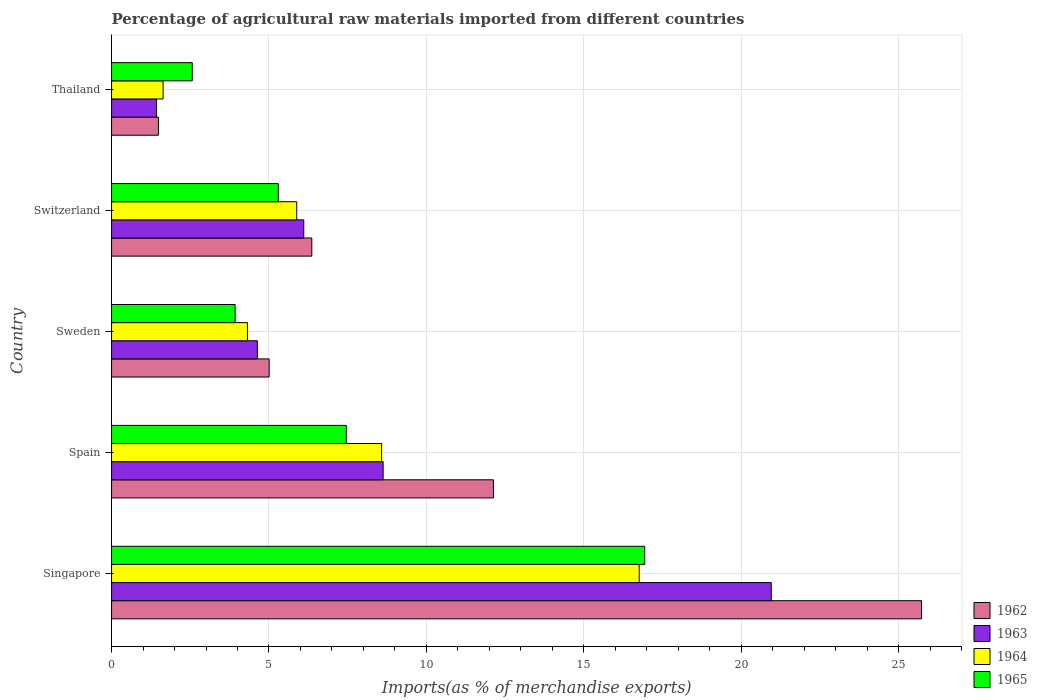How many bars are there on the 2nd tick from the top?
Provide a short and direct response. 4. What is the label of the 5th group of bars from the top?
Make the answer very short. Singapore. In how many cases, is the number of bars for a given country not equal to the number of legend labels?
Offer a terse response. 0. What is the percentage of imports to different countries in 1965 in Spain?
Your answer should be very brief. 7.46. Across all countries, what is the maximum percentage of imports to different countries in 1965?
Your response must be concise. 16.93. Across all countries, what is the minimum percentage of imports to different countries in 1963?
Your response must be concise. 1.43. In which country was the percentage of imports to different countries in 1963 maximum?
Provide a succinct answer. Singapore. In which country was the percentage of imports to different countries in 1965 minimum?
Give a very brief answer. Thailand. What is the total percentage of imports to different countries in 1963 in the graph?
Provide a short and direct response. 41.74. What is the difference between the percentage of imports to different countries in 1963 in Spain and that in Sweden?
Your answer should be very brief. 4. What is the difference between the percentage of imports to different countries in 1965 in Sweden and the percentage of imports to different countries in 1963 in Spain?
Make the answer very short. -4.7. What is the average percentage of imports to different countries in 1963 per country?
Ensure brevity in your answer.  8.35. What is the difference between the percentage of imports to different countries in 1965 and percentage of imports to different countries in 1962 in Sweden?
Offer a terse response. -1.08. What is the ratio of the percentage of imports to different countries in 1963 in Singapore to that in Thailand?
Offer a very short reply. 14.66. Is the percentage of imports to different countries in 1963 in Singapore less than that in Sweden?
Offer a terse response. No. What is the difference between the highest and the second highest percentage of imports to different countries in 1962?
Give a very brief answer. 13.6. What is the difference between the highest and the lowest percentage of imports to different countries in 1962?
Provide a succinct answer. 24.24. In how many countries, is the percentage of imports to different countries in 1962 greater than the average percentage of imports to different countries in 1962 taken over all countries?
Your answer should be very brief. 2. Is it the case that in every country, the sum of the percentage of imports to different countries in 1964 and percentage of imports to different countries in 1965 is greater than the sum of percentage of imports to different countries in 1963 and percentage of imports to different countries in 1962?
Keep it short and to the point. No. What does the 3rd bar from the top in Spain represents?
Offer a terse response. 1963. What does the 4th bar from the bottom in Sweden represents?
Give a very brief answer. 1965. How many bars are there?
Provide a short and direct response. 20. How many countries are there in the graph?
Keep it short and to the point. 5. What is the difference between two consecutive major ticks on the X-axis?
Your answer should be very brief. 5. Does the graph contain grids?
Keep it short and to the point. Yes. How many legend labels are there?
Provide a succinct answer. 4. How are the legend labels stacked?
Your answer should be very brief. Vertical. What is the title of the graph?
Provide a short and direct response. Percentage of agricultural raw materials imported from different countries. Does "1962" appear as one of the legend labels in the graph?
Give a very brief answer. Yes. What is the label or title of the X-axis?
Your response must be concise. Imports(as % of merchandise exports). What is the label or title of the Y-axis?
Keep it short and to the point. Country. What is the Imports(as % of merchandise exports) in 1962 in Singapore?
Offer a terse response. 25.73. What is the Imports(as % of merchandise exports) in 1963 in Singapore?
Make the answer very short. 20.95. What is the Imports(as % of merchandise exports) of 1964 in Singapore?
Ensure brevity in your answer.  16.76. What is the Imports(as % of merchandise exports) of 1965 in Singapore?
Make the answer very short. 16.93. What is the Imports(as % of merchandise exports) in 1962 in Spain?
Your response must be concise. 12.13. What is the Imports(as % of merchandise exports) of 1963 in Spain?
Your answer should be compact. 8.63. What is the Imports(as % of merchandise exports) in 1964 in Spain?
Your response must be concise. 8.58. What is the Imports(as % of merchandise exports) of 1965 in Spain?
Your answer should be very brief. 7.46. What is the Imports(as % of merchandise exports) of 1962 in Sweden?
Ensure brevity in your answer.  5.01. What is the Imports(as % of merchandise exports) in 1963 in Sweden?
Ensure brevity in your answer.  4.63. What is the Imports(as % of merchandise exports) of 1964 in Sweden?
Make the answer very short. 4.32. What is the Imports(as % of merchandise exports) of 1965 in Sweden?
Your answer should be compact. 3.92. What is the Imports(as % of merchandise exports) in 1962 in Switzerland?
Offer a terse response. 6.36. What is the Imports(as % of merchandise exports) of 1963 in Switzerland?
Offer a very short reply. 6.1. What is the Imports(as % of merchandise exports) of 1964 in Switzerland?
Your answer should be compact. 5.88. What is the Imports(as % of merchandise exports) of 1965 in Switzerland?
Ensure brevity in your answer.  5.3. What is the Imports(as % of merchandise exports) in 1962 in Thailand?
Your answer should be very brief. 1.49. What is the Imports(as % of merchandise exports) in 1963 in Thailand?
Provide a succinct answer. 1.43. What is the Imports(as % of merchandise exports) of 1964 in Thailand?
Offer a terse response. 1.64. What is the Imports(as % of merchandise exports) in 1965 in Thailand?
Provide a short and direct response. 2.56. Across all countries, what is the maximum Imports(as % of merchandise exports) of 1962?
Provide a short and direct response. 25.73. Across all countries, what is the maximum Imports(as % of merchandise exports) of 1963?
Ensure brevity in your answer.  20.95. Across all countries, what is the maximum Imports(as % of merchandise exports) in 1964?
Your response must be concise. 16.76. Across all countries, what is the maximum Imports(as % of merchandise exports) in 1965?
Your answer should be very brief. 16.93. Across all countries, what is the minimum Imports(as % of merchandise exports) in 1962?
Keep it short and to the point. 1.49. Across all countries, what is the minimum Imports(as % of merchandise exports) in 1963?
Keep it short and to the point. 1.43. Across all countries, what is the minimum Imports(as % of merchandise exports) of 1964?
Your response must be concise. 1.64. Across all countries, what is the minimum Imports(as % of merchandise exports) of 1965?
Make the answer very short. 2.56. What is the total Imports(as % of merchandise exports) of 1962 in the graph?
Provide a succinct answer. 50.71. What is the total Imports(as % of merchandise exports) in 1963 in the graph?
Your answer should be compact. 41.74. What is the total Imports(as % of merchandise exports) in 1964 in the graph?
Offer a terse response. 37.17. What is the total Imports(as % of merchandise exports) in 1965 in the graph?
Your answer should be very brief. 36.18. What is the difference between the Imports(as % of merchandise exports) of 1962 in Singapore and that in Spain?
Your answer should be compact. 13.6. What is the difference between the Imports(as % of merchandise exports) in 1963 in Singapore and that in Spain?
Provide a succinct answer. 12.33. What is the difference between the Imports(as % of merchandise exports) in 1964 in Singapore and that in Spain?
Offer a very short reply. 8.18. What is the difference between the Imports(as % of merchandise exports) in 1965 in Singapore and that in Spain?
Your answer should be very brief. 9.48. What is the difference between the Imports(as % of merchandise exports) in 1962 in Singapore and that in Sweden?
Give a very brief answer. 20.72. What is the difference between the Imports(as % of merchandise exports) in 1963 in Singapore and that in Sweden?
Provide a short and direct response. 16.32. What is the difference between the Imports(as % of merchandise exports) of 1964 in Singapore and that in Sweden?
Ensure brevity in your answer.  12.44. What is the difference between the Imports(as % of merchandise exports) of 1965 in Singapore and that in Sweden?
Provide a succinct answer. 13.01. What is the difference between the Imports(as % of merchandise exports) of 1962 in Singapore and that in Switzerland?
Your answer should be compact. 19.37. What is the difference between the Imports(as % of merchandise exports) in 1963 in Singapore and that in Switzerland?
Your response must be concise. 14.85. What is the difference between the Imports(as % of merchandise exports) of 1964 in Singapore and that in Switzerland?
Your response must be concise. 10.88. What is the difference between the Imports(as % of merchandise exports) of 1965 in Singapore and that in Switzerland?
Make the answer very short. 11.64. What is the difference between the Imports(as % of merchandise exports) in 1962 in Singapore and that in Thailand?
Your response must be concise. 24.24. What is the difference between the Imports(as % of merchandise exports) of 1963 in Singapore and that in Thailand?
Offer a terse response. 19.52. What is the difference between the Imports(as % of merchandise exports) of 1964 in Singapore and that in Thailand?
Provide a short and direct response. 15.12. What is the difference between the Imports(as % of merchandise exports) of 1965 in Singapore and that in Thailand?
Keep it short and to the point. 14.37. What is the difference between the Imports(as % of merchandise exports) in 1962 in Spain and that in Sweden?
Make the answer very short. 7.12. What is the difference between the Imports(as % of merchandise exports) of 1963 in Spain and that in Sweden?
Make the answer very short. 4. What is the difference between the Imports(as % of merchandise exports) of 1964 in Spain and that in Sweden?
Make the answer very short. 4.26. What is the difference between the Imports(as % of merchandise exports) of 1965 in Spain and that in Sweden?
Keep it short and to the point. 3.53. What is the difference between the Imports(as % of merchandise exports) of 1962 in Spain and that in Switzerland?
Your response must be concise. 5.77. What is the difference between the Imports(as % of merchandise exports) of 1963 in Spain and that in Switzerland?
Provide a succinct answer. 2.52. What is the difference between the Imports(as % of merchandise exports) of 1964 in Spain and that in Switzerland?
Offer a terse response. 2.7. What is the difference between the Imports(as % of merchandise exports) in 1965 in Spain and that in Switzerland?
Your answer should be compact. 2.16. What is the difference between the Imports(as % of merchandise exports) in 1962 in Spain and that in Thailand?
Offer a terse response. 10.64. What is the difference between the Imports(as % of merchandise exports) of 1963 in Spain and that in Thailand?
Your answer should be compact. 7.2. What is the difference between the Imports(as % of merchandise exports) of 1964 in Spain and that in Thailand?
Provide a succinct answer. 6.94. What is the difference between the Imports(as % of merchandise exports) of 1965 in Spain and that in Thailand?
Ensure brevity in your answer.  4.89. What is the difference between the Imports(as % of merchandise exports) in 1962 in Sweden and that in Switzerland?
Give a very brief answer. -1.35. What is the difference between the Imports(as % of merchandise exports) of 1963 in Sweden and that in Switzerland?
Ensure brevity in your answer.  -1.47. What is the difference between the Imports(as % of merchandise exports) of 1964 in Sweden and that in Switzerland?
Make the answer very short. -1.57. What is the difference between the Imports(as % of merchandise exports) of 1965 in Sweden and that in Switzerland?
Provide a short and direct response. -1.37. What is the difference between the Imports(as % of merchandise exports) in 1962 in Sweden and that in Thailand?
Offer a terse response. 3.52. What is the difference between the Imports(as % of merchandise exports) of 1963 in Sweden and that in Thailand?
Your answer should be very brief. 3.2. What is the difference between the Imports(as % of merchandise exports) in 1964 in Sweden and that in Thailand?
Ensure brevity in your answer.  2.68. What is the difference between the Imports(as % of merchandise exports) of 1965 in Sweden and that in Thailand?
Ensure brevity in your answer.  1.36. What is the difference between the Imports(as % of merchandise exports) in 1962 in Switzerland and that in Thailand?
Your answer should be very brief. 4.87. What is the difference between the Imports(as % of merchandise exports) of 1963 in Switzerland and that in Thailand?
Ensure brevity in your answer.  4.68. What is the difference between the Imports(as % of merchandise exports) in 1964 in Switzerland and that in Thailand?
Provide a short and direct response. 4.24. What is the difference between the Imports(as % of merchandise exports) of 1965 in Switzerland and that in Thailand?
Provide a succinct answer. 2.73. What is the difference between the Imports(as % of merchandise exports) of 1962 in Singapore and the Imports(as % of merchandise exports) of 1963 in Spain?
Your answer should be very brief. 17.1. What is the difference between the Imports(as % of merchandise exports) in 1962 in Singapore and the Imports(as % of merchandise exports) in 1964 in Spain?
Provide a succinct answer. 17.15. What is the difference between the Imports(as % of merchandise exports) in 1962 in Singapore and the Imports(as % of merchandise exports) in 1965 in Spain?
Provide a succinct answer. 18.27. What is the difference between the Imports(as % of merchandise exports) in 1963 in Singapore and the Imports(as % of merchandise exports) in 1964 in Spain?
Provide a succinct answer. 12.38. What is the difference between the Imports(as % of merchandise exports) of 1963 in Singapore and the Imports(as % of merchandise exports) of 1965 in Spain?
Keep it short and to the point. 13.5. What is the difference between the Imports(as % of merchandise exports) of 1964 in Singapore and the Imports(as % of merchandise exports) of 1965 in Spain?
Offer a terse response. 9.3. What is the difference between the Imports(as % of merchandise exports) in 1962 in Singapore and the Imports(as % of merchandise exports) in 1963 in Sweden?
Offer a terse response. 21.09. What is the difference between the Imports(as % of merchandise exports) of 1962 in Singapore and the Imports(as % of merchandise exports) of 1964 in Sweden?
Provide a succinct answer. 21.41. What is the difference between the Imports(as % of merchandise exports) of 1962 in Singapore and the Imports(as % of merchandise exports) of 1965 in Sweden?
Your answer should be compact. 21.8. What is the difference between the Imports(as % of merchandise exports) of 1963 in Singapore and the Imports(as % of merchandise exports) of 1964 in Sweden?
Your answer should be compact. 16.64. What is the difference between the Imports(as % of merchandise exports) of 1963 in Singapore and the Imports(as % of merchandise exports) of 1965 in Sweden?
Provide a succinct answer. 17.03. What is the difference between the Imports(as % of merchandise exports) in 1964 in Singapore and the Imports(as % of merchandise exports) in 1965 in Sweden?
Give a very brief answer. 12.83. What is the difference between the Imports(as % of merchandise exports) in 1962 in Singapore and the Imports(as % of merchandise exports) in 1963 in Switzerland?
Offer a terse response. 19.62. What is the difference between the Imports(as % of merchandise exports) of 1962 in Singapore and the Imports(as % of merchandise exports) of 1964 in Switzerland?
Your answer should be compact. 19.84. What is the difference between the Imports(as % of merchandise exports) in 1962 in Singapore and the Imports(as % of merchandise exports) in 1965 in Switzerland?
Ensure brevity in your answer.  20.43. What is the difference between the Imports(as % of merchandise exports) in 1963 in Singapore and the Imports(as % of merchandise exports) in 1964 in Switzerland?
Your answer should be compact. 15.07. What is the difference between the Imports(as % of merchandise exports) in 1963 in Singapore and the Imports(as % of merchandise exports) in 1965 in Switzerland?
Ensure brevity in your answer.  15.66. What is the difference between the Imports(as % of merchandise exports) in 1964 in Singapore and the Imports(as % of merchandise exports) in 1965 in Switzerland?
Provide a succinct answer. 11.46. What is the difference between the Imports(as % of merchandise exports) in 1962 in Singapore and the Imports(as % of merchandise exports) in 1963 in Thailand?
Keep it short and to the point. 24.3. What is the difference between the Imports(as % of merchandise exports) in 1962 in Singapore and the Imports(as % of merchandise exports) in 1964 in Thailand?
Your answer should be compact. 24.09. What is the difference between the Imports(as % of merchandise exports) in 1962 in Singapore and the Imports(as % of merchandise exports) in 1965 in Thailand?
Give a very brief answer. 23.16. What is the difference between the Imports(as % of merchandise exports) in 1963 in Singapore and the Imports(as % of merchandise exports) in 1964 in Thailand?
Provide a short and direct response. 19.32. What is the difference between the Imports(as % of merchandise exports) of 1963 in Singapore and the Imports(as % of merchandise exports) of 1965 in Thailand?
Provide a short and direct response. 18.39. What is the difference between the Imports(as % of merchandise exports) of 1964 in Singapore and the Imports(as % of merchandise exports) of 1965 in Thailand?
Offer a very short reply. 14.2. What is the difference between the Imports(as % of merchandise exports) in 1962 in Spain and the Imports(as % of merchandise exports) in 1963 in Sweden?
Your response must be concise. 7.5. What is the difference between the Imports(as % of merchandise exports) in 1962 in Spain and the Imports(as % of merchandise exports) in 1964 in Sweden?
Your response must be concise. 7.81. What is the difference between the Imports(as % of merchandise exports) in 1962 in Spain and the Imports(as % of merchandise exports) in 1965 in Sweden?
Keep it short and to the point. 8.21. What is the difference between the Imports(as % of merchandise exports) in 1963 in Spain and the Imports(as % of merchandise exports) in 1964 in Sweden?
Offer a very short reply. 4.31. What is the difference between the Imports(as % of merchandise exports) in 1963 in Spain and the Imports(as % of merchandise exports) in 1965 in Sweden?
Your answer should be very brief. 4.7. What is the difference between the Imports(as % of merchandise exports) of 1964 in Spain and the Imports(as % of merchandise exports) of 1965 in Sweden?
Make the answer very short. 4.65. What is the difference between the Imports(as % of merchandise exports) in 1962 in Spain and the Imports(as % of merchandise exports) in 1963 in Switzerland?
Provide a succinct answer. 6.02. What is the difference between the Imports(as % of merchandise exports) in 1962 in Spain and the Imports(as % of merchandise exports) in 1964 in Switzerland?
Your answer should be compact. 6.25. What is the difference between the Imports(as % of merchandise exports) of 1962 in Spain and the Imports(as % of merchandise exports) of 1965 in Switzerland?
Your answer should be compact. 6.83. What is the difference between the Imports(as % of merchandise exports) of 1963 in Spain and the Imports(as % of merchandise exports) of 1964 in Switzerland?
Make the answer very short. 2.74. What is the difference between the Imports(as % of merchandise exports) of 1963 in Spain and the Imports(as % of merchandise exports) of 1965 in Switzerland?
Keep it short and to the point. 3.33. What is the difference between the Imports(as % of merchandise exports) in 1964 in Spain and the Imports(as % of merchandise exports) in 1965 in Switzerland?
Your response must be concise. 3.28. What is the difference between the Imports(as % of merchandise exports) of 1962 in Spain and the Imports(as % of merchandise exports) of 1963 in Thailand?
Provide a succinct answer. 10.7. What is the difference between the Imports(as % of merchandise exports) of 1962 in Spain and the Imports(as % of merchandise exports) of 1964 in Thailand?
Keep it short and to the point. 10.49. What is the difference between the Imports(as % of merchandise exports) of 1962 in Spain and the Imports(as % of merchandise exports) of 1965 in Thailand?
Make the answer very short. 9.57. What is the difference between the Imports(as % of merchandise exports) in 1963 in Spain and the Imports(as % of merchandise exports) in 1964 in Thailand?
Your answer should be very brief. 6.99. What is the difference between the Imports(as % of merchandise exports) of 1963 in Spain and the Imports(as % of merchandise exports) of 1965 in Thailand?
Your response must be concise. 6.06. What is the difference between the Imports(as % of merchandise exports) in 1964 in Spain and the Imports(as % of merchandise exports) in 1965 in Thailand?
Your answer should be compact. 6.01. What is the difference between the Imports(as % of merchandise exports) of 1962 in Sweden and the Imports(as % of merchandise exports) of 1963 in Switzerland?
Your answer should be very brief. -1.1. What is the difference between the Imports(as % of merchandise exports) in 1962 in Sweden and the Imports(as % of merchandise exports) in 1964 in Switzerland?
Your answer should be very brief. -0.88. What is the difference between the Imports(as % of merchandise exports) in 1962 in Sweden and the Imports(as % of merchandise exports) in 1965 in Switzerland?
Keep it short and to the point. -0.29. What is the difference between the Imports(as % of merchandise exports) in 1963 in Sweden and the Imports(as % of merchandise exports) in 1964 in Switzerland?
Offer a very short reply. -1.25. What is the difference between the Imports(as % of merchandise exports) in 1963 in Sweden and the Imports(as % of merchandise exports) in 1965 in Switzerland?
Your response must be concise. -0.67. What is the difference between the Imports(as % of merchandise exports) in 1964 in Sweden and the Imports(as % of merchandise exports) in 1965 in Switzerland?
Offer a very short reply. -0.98. What is the difference between the Imports(as % of merchandise exports) of 1962 in Sweden and the Imports(as % of merchandise exports) of 1963 in Thailand?
Offer a terse response. 3.58. What is the difference between the Imports(as % of merchandise exports) in 1962 in Sweden and the Imports(as % of merchandise exports) in 1964 in Thailand?
Your answer should be very brief. 3.37. What is the difference between the Imports(as % of merchandise exports) of 1962 in Sweden and the Imports(as % of merchandise exports) of 1965 in Thailand?
Your answer should be compact. 2.44. What is the difference between the Imports(as % of merchandise exports) of 1963 in Sweden and the Imports(as % of merchandise exports) of 1964 in Thailand?
Give a very brief answer. 2.99. What is the difference between the Imports(as % of merchandise exports) in 1963 in Sweden and the Imports(as % of merchandise exports) in 1965 in Thailand?
Ensure brevity in your answer.  2.07. What is the difference between the Imports(as % of merchandise exports) of 1964 in Sweden and the Imports(as % of merchandise exports) of 1965 in Thailand?
Provide a short and direct response. 1.75. What is the difference between the Imports(as % of merchandise exports) of 1962 in Switzerland and the Imports(as % of merchandise exports) of 1963 in Thailand?
Offer a terse response. 4.93. What is the difference between the Imports(as % of merchandise exports) of 1962 in Switzerland and the Imports(as % of merchandise exports) of 1964 in Thailand?
Ensure brevity in your answer.  4.72. What is the difference between the Imports(as % of merchandise exports) of 1962 in Switzerland and the Imports(as % of merchandise exports) of 1965 in Thailand?
Give a very brief answer. 3.8. What is the difference between the Imports(as % of merchandise exports) in 1963 in Switzerland and the Imports(as % of merchandise exports) in 1964 in Thailand?
Ensure brevity in your answer.  4.47. What is the difference between the Imports(as % of merchandise exports) of 1963 in Switzerland and the Imports(as % of merchandise exports) of 1965 in Thailand?
Ensure brevity in your answer.  3.54. What is the difference between the Imports(as % of merchandise exports) in 1964 in Switzerland and the Imports(as % of merchandise exports) in 1965 in Thailand?
Give a very brief answer. 3.32. What is the average Imports(as % of merchandise exports) in 1962 per country?
Offer a terse response. 10.14. What is the average Imports(as % of merchandise exports) of 1963 per country?
Your answer should be compact. 8.35. What is the average Imports(as % of merchandise exports) in 1964 per country?
Offer a terse response. 7.43. What is the average Imports(as % of merchandise exports) of 1965 per country?
Your response must be concise. 7.24. What is the difference between the Imports(as % of merchandise exports) in 1962 and Imports(as % of merchandise exports) in 1963 in Singapore?
Your response must be concise. 4.77. What is the difference between the Imports(as % of merchandise exports) of 1962 and Imports(as % of merchandise exports) of 1964 in Singapore?
Provide a succinct answer. 8.97. What is the difference between the Imports(as % of merchandise exports) of 1962 and Imports(as % of merchandise exports) of 1965 in Singapore?
Your answer should be very brief. 8.79. What is the difference between the Imports(as % of merchandise exports) of 1963 and Imports(as % of merchandise exports) of 1964 in Singapore?
Provide a short and direct response. 4.19. What is the difference between the Imports(as % of merchandise exports) in 1963 and Imports(as % of merchandise exports) in 1965 in Singapore?
Ensure brevity in your answer.  4.02. What is the difference between the Imports(as % of merchandise exports) of 1964 and Imports(as % of merchandise exports) of 1965 in Singapore?
Offer a terse response. -0.18. What is the difference between the Imports(as % of merchandise exports) of 1962 and Imports(as % of merchandise exports) of 1963 in Spain?
Offer a terse response. 3.5. What is the difference between the Imports(as % of merchandise exports) of 1962 and Imports(as % of merchandise exports) of 1964 in Spain?
Keep it short and to the point. 3.55. What is the difference between the Imports(as % of merchandise exports) in 1962 and Imports(as % of merchandise exports) in 1965 in Spain?
Make the answer very short. 4.67. What is the difference between the Imports(as % of merchandise exports) of 1963 and Imports(as % of merchandise exports) of 1964 in Spain?
Your answer should be compact. 0.05. What is the difference between the Imports(as % of merchandise exports) of 1963 and Imports(as % of merchandise exports) of 1965 in Spain?
Ensure brevity in your answer.  1.17. What is the difference between the Imports(as % of merchandise exports) in 1964 and Imports(as % of merchandise exports) in 1965 in Spain?
Your answer should be compact. 1.12. What is the difference between the Imports(as % of merchandise exports) of 1962 and Imports(as % of merchandise exports) of 1963 in Sweden?
Make the answer very short. 0.38. What is the difference between the Imports(as % of merchandise exports) of 1962 and Imports(as % of merchandise exports) of 1964 in Sweden?
Keep it short and to the point. 0.69. What is the difference between the Imports(as % of merchandise exports) in 1962 and Imports(as % of merchandise exports) in 1965 in Sweden?
Provide a short and direct response. 1.08. What is the difference between the Imports(as % of merchandise exports) in 1963 and Imports(as % of merchandise exports) in 1964 in Sweden?
Ensure brevity in your answer.  0.31. What is the difference between the Imports(as % of merchandise exports) in 1963 and Imports(as % of merchandise exports) in 1965 in Sweden?
Keep it short and to the point. 0.71. What is the difference between the Imports(as % of merchandise exports) in 1964 and Imports(as % of merchandise exports) in 1965 in Sweden?
Your answer should be compact. 0.39. What is the difference between the Imports(as % of merchandise exports) of 1962 and Imports(as % of merchandise exports) of 1963 in Switzerland?
Ensure brevity in your answer.  0.26. What is the difference between the Imports(as % of merchandise exports) in 1962 and Imports(as % of merchandise exports) in 1964 in Switzerland?
Your answer should be very brief. 0.48. What is the difference between the Imports(as % of merchandise exports) of 1962 and Imports(as % of merchandise exports) of 1965 in Switzerland?
Your response must be concise. 1.06. What is the difference between the Imports(as % of merchandise exports) in 1963 and Imports(as % of merchandise exports) in 1964 in Switzerland?
Keep it short and to the point. 0.22. What is the difference between the Imports(as % of merchandise exports) of 1963 and Imports(as % of merchandise exports) of 1965 in Switzerland?
Make the answer very short. 0.81. What is the difference between the Imports(as % of merchandise exports) of 1964 and Imports(as % of merchandise exports) of 1965 in Switzerland?
Provide a short and direct response. 0.58. What is the difference between the Imports(as % of merchandise exports) of 1962 and Imports(as % of merchandise exports) of 1963 in Thailand?
Your answer should be very brief. 0.06. What is the difference between the Imports(as % of merchandise exports) in 1962 and Imports(as % of merchandise exports) in 1964 in Thailand?
Provide a succinct answer. -0.15. What is the difference between the Imports(as % of merchandise exports) of 1962 and Imports(as % of merchandise exports) of 1965 in Thailand?
Keep it short and to the point. -1.08. What is the difference between the Imports(as % of merchandise exports) in 1963 and Imports(as % of merchandise exports) in 1964 in Thailand?
Your response must be concise. -0.21. What is the difference between the Imports(as % of merchandise exports) in 1963 and Imports(as % of merchandise exports) in 1965 in Thailand?
Your answer should be very brief. -1.13. What is the difference between the Imports(as % of merchandise exports) of 1964 and Imports(as % of merchandise exports) of 1965 in Thailand?
Your answer should be compact. -0.93. What is the ratio of the Imports(as % of merchandise exports) in 1962 in Singapore to that in Spain?
Give a very brief answer. 2.12. What is the ratio of the Imports(as % of merchandise exports) in 1963 in Singapore to that in Spain?
Provide a short and direct response. 2.43. What is the ratio of the Imports(as % of merchandise exports) in 1964 in Singapore to that in Spain?
Give a very brief answer. 1.95. What is the ratio of the Imports(as % of merchandise exports) of 1965 in Singapore to that in Spain?
Keep it short and to the point. 2.27. What is the ratio of the Imports(as % of merchandise exports) in 1962 in Singapore to that in Sweden?
Provide a short and direct response. 5.14. What is the ratio of the Imports(as % of merchandise exports) of 1963 in Singapore to that in Sweden?
Give a very brief answer. 4.53. What is the ratio of the Imports(as % of merchandise exports) in 1964 in Singapore to that in Sweden?
Provide a succinct answer. 3.88. What is the ratio of the Imports(as % of merchandise exports) in 1965 in Singapore to that in Sweden?
Ensure brevity in your answer.  4.32. What is the ratio of the Imports(as % of merchandise exports) in 1962 in Singapore to that in Switzerland?
Offer a very short reply. 4.04. What is the ratio of the Imports(as % of merchandise exports) of 1963 in Singapore to that in Switzerland?
Provide a succinct answer. 3.43. What is the ratio of the Imports(as % of merchandise exports) of 1964 in Singapore to that in Switzerland?
Your answer should be compact. 2.85. What is the ratio of the Imports(as % of merchandise exports) in 1965 in Singapore to that in Switzerland?
Offer a terse response. 3.2. What is the ratio of the Imports(as % of merchandise exports) in 1962 in Singapore to that in Thailand?
Give a very brief answer. 17.28. What is the ratio of the Imports(as % of merchandise exports) of 1963 in Singapore to that in Thailand?
Give a very brief answer. 14.66. What is the ratio of the Imports(as % of merchandise exports) in 1964 in Singapore to that in Thailand?
Give a very brief answer. 10.23. What is the ratio of the Imports(as % of merchandise exports) in 1965 in Singapore to that in Thailand?
Your response must be concise. 6.6. What is the ratio of the Imports(as % of merchandise exports) of 1962 in Spain to that in Sweden?
Your answer should be very brief. 2.42. What is the ratio of the Imports(as % of merchandise exports) in 1963 in Spain to that in Sweden?
Provide a short and direct response. 1.86. What is the ratio of the Imports(as % of merchandise exports) in 1964 in Spain to that in Sweden?
Make the answer very short. 1.99. What is the ratio of the Imports(as % of merchandise exports) in 1965 in Spain to that in Sweden?
Your response must be concise. 1.9. What is the ratio of the Imports(as % of merchandise exports) of 1962 in Spain to that in Switzerland?
Ensure brevity in your answer.  1.91. What is the ratio of the Imports(as % of merchandise exports) of 1963 in Spain to that in Switzerland?
Your response must be concise. 1.41. What is the ratio of the Imports(as % of merchandise exports) in 1964 in Spain to that in Switzerland?
Provide a short and direct response. 1.46. What is the ratio of the Imports(as % of merchandise exports) in 1965 in Spain to that in Switzerland?
Keep it short and to the point. 1.41. What is the ratio of the Imports(as % of merchandise exports) of 1962 in Spain to that in Thailand?
Offer a very short reply. 8.15. What is the ratio of the Imports(as % of merchandise exports) of 1963 in Spain to that in Thailand?
Ensure brevity in your answer.  6.03. What is the ratio of the Imports(as % of merchandise exports) of 1964 in Spain to that in Thailand?
Offer a terse response. 5.24. What is the ratio of the Imports(as % of merchandise exports) of 1965 in Spain to that in Thailand?
Your response must be concise. 2.91. What is the ratio of the Imports(as % of merchandise exports) of 1962 in Sweden to that in Switzerland?
Provide a succinct answer. 0.79. What is the ratio of the Imports(as % of merchandise exports) of 1963 in Sweden to that in Switzerland?
Your response must be concise. 0.76. What is the ratio of the Imports(as % of merchandise exports) in 1964 in Sweden to that in Switzerland?
Make the answer very short. 0.73. What is the ratio of the Imports(as % of merchandise exports) in 1965 in Sweden to that in Switzerland?
Provide a short and direct response. 0.74. What is the ratio of the Imports(as % of merchandise exports) in 1962 in Sweden to that in Thailand?
Make the answer very short. 3.36. What is the ratio of the Imports(as % of merchandise exports) of 1963 in Sweden to that in Thailand?
Your answer should be very brief. 3.24. What is the ratio of the Imports(as % of merchandise exports) of 1964 in Sweden to that in Thailand?
Give a very brief answer. 2.64. What is the ratio of the Imports(as % of merchandise exports) of 1965 in Sweden to that in Thailand?
Offer a terse response. 1.53. What is the ratio of the Imports(as % of merchandise exports) of 1962 in Switzerland to that in Thailand?
Keep it short and to the point. 4.27. What is the ratio of the Imports(as % of merchandise exports) in 1963 in Switzerland to that in Thailand?
Your answer should be very brief. 4.27. What is the ratio of the Imports(as % of merchandise exports) of 1964 in Switzerland to that in Thailand?
Your answer should be very brief. 3.59. What is the ratio of the Imports(as % of merchandise exports) of 1965 in Switzerland to that in Thailand?
Provide a succinct answer. 2.07. What is the difference between the highest and the second highest Imports(as % of merchandise exports) of 1962?
Give a very brief answer. 13.6. What is the difference between the highest and the second highest Imports(as % of merchandise exports) of 1963?
Give a very brief answer. 12.33. What is the difference between the highest and the second highest Imports(as % of merchandise exports) in 1964?
Your answer should be very brief. 8.18. What is the difference between the highest and the second highest Imports(as % of merchandise exports) in 1965?
Provide a succinct answer. 9.48. What is the difference between the highest and the lowest Imports(as % of merchandise exports) of 1962?
Provide a succinct answer. 24.24. What is the difference between the highest and the lowest Imports(as % of merchandise exports) in 1963?
Offer a very short reply. 19.52. What is the difference between the highest and the lowest Imports(as % of merchandise exports) in 1964?
Give a very brief answer. 15.12. What is the difference between the highest and the lowest Imports(as % of merchandise exports) in 1965?
Your response must be concise. 14.37. 